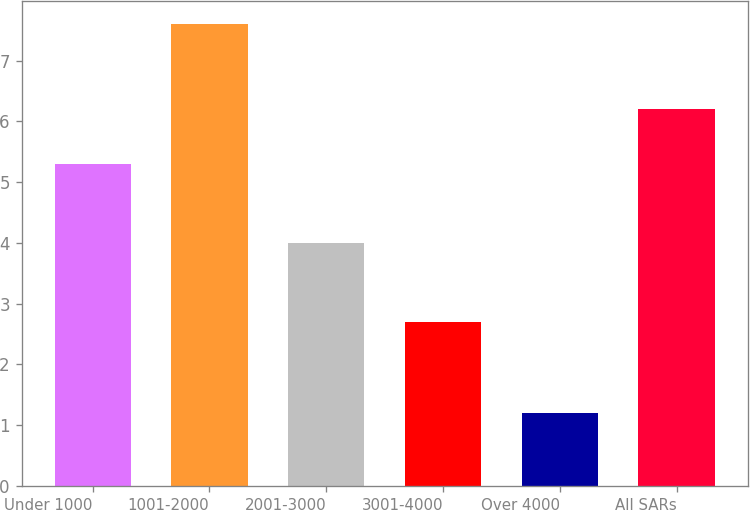Convert chart. <chart><loc_0><loc_0><loc_500><loc_500><bar_chart><fcel>Under 1000<fcel>1001-2000<fcel>2001-3000<fcel>3001-4000<fcel>Over 4000<fcel>All SARs<nl><fcel>5.3<fcel>7.6<fcel>4<fcel>2.7<fcel>1.2<fcel>6.2<nl></chart> 